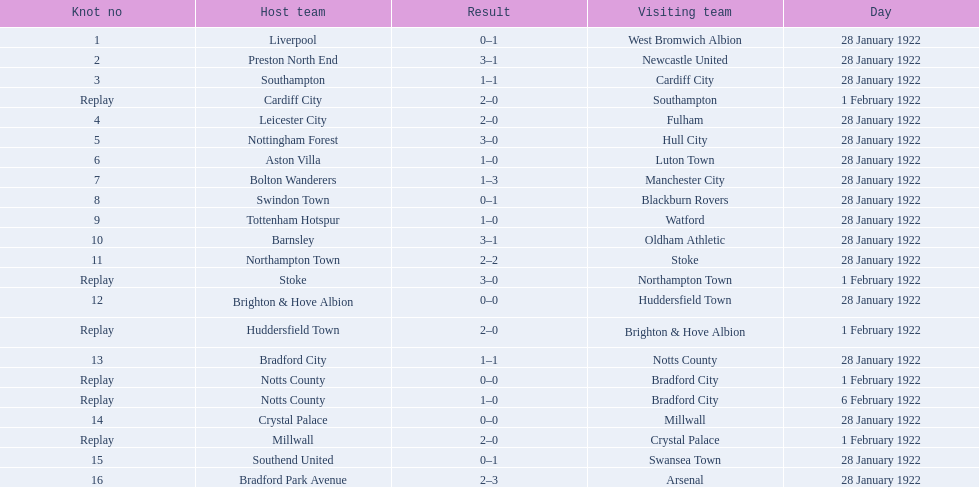What date did they play before feb 1? 28 January 1922. Could you parse the entire table? {'header': ['Knot no', 'Host team', 'Result', 'Visiting team', 'Day'], 'rows': [['1', 'Liverpool', '0–1', 'West Bromwich Albion', '28 January 1922'], ['2', 'Preston North End', '3–1', 'Newcastle United', '28 January 1922'], ['3', 'Southampton', '1–1', 'Cardiff City', '28 January 1922'], ['Replay', 'Cardiff City', '2–0', 'Southampton', '1 February 1922'], ['4', 'Leicester City', '2–0', 'Fulham', '28 January 1922'], ['5', 'Nottingham Forest', '3–0', 'Hull City', '28 January 1922'], ['6', 'Aston Villa', '1–0', 'Luton Town', '28 January 1922'], ['7', 'Bolton Wanderers', '1–3', 'Manchester City', '28 January 1922'], ['8', 'Swindon Town', '0–1', 'Blackburn Rovers', '28 January 1922'], ['9', 'Tottenham Hotspur', '1–0', 'Watford', '28 January 1922'], ['10', 'Barnsley', '3–1', 'Oldham Athletic', '28 January 1922'], ['11', 'Northampton Town', '2–2', 'Stoke', '28 January 1922'], ['Replay', 'Stoke', '3–0', 'Northampton Town', '1 February 1922'], ['12', 'Brighton & Hove Albion', '0–0', 'Huddersfield Town', '28 January 1922'], ['Replay', 'Huddersfield Town', '2–0', 'Brighton & Hove Albion', '1 February 1922'], ['13', 'Bradford City', '1–1', 'Notts County', '28 January 1922'], ['Replay', 'Notts County', '0–0', 'Bradford City', '1 February 1922'], ['Replay', 'Notts County', '1–0', 'Bradford City', '6 February 1922'], ['14', 'Crystal Palace', '0–0', 'Millwall', '28 January 1922'], ['Replay', 'Millwall', '2–0', 'Crystal Palace', '1 February 1922'], ['15', 'Southend United', '0–1', 'Swansea Town', '28 January 1922'], ['16', 'Bradford Park Avenue', '2–3', 'Arsenal', '28 January 1922']]} 